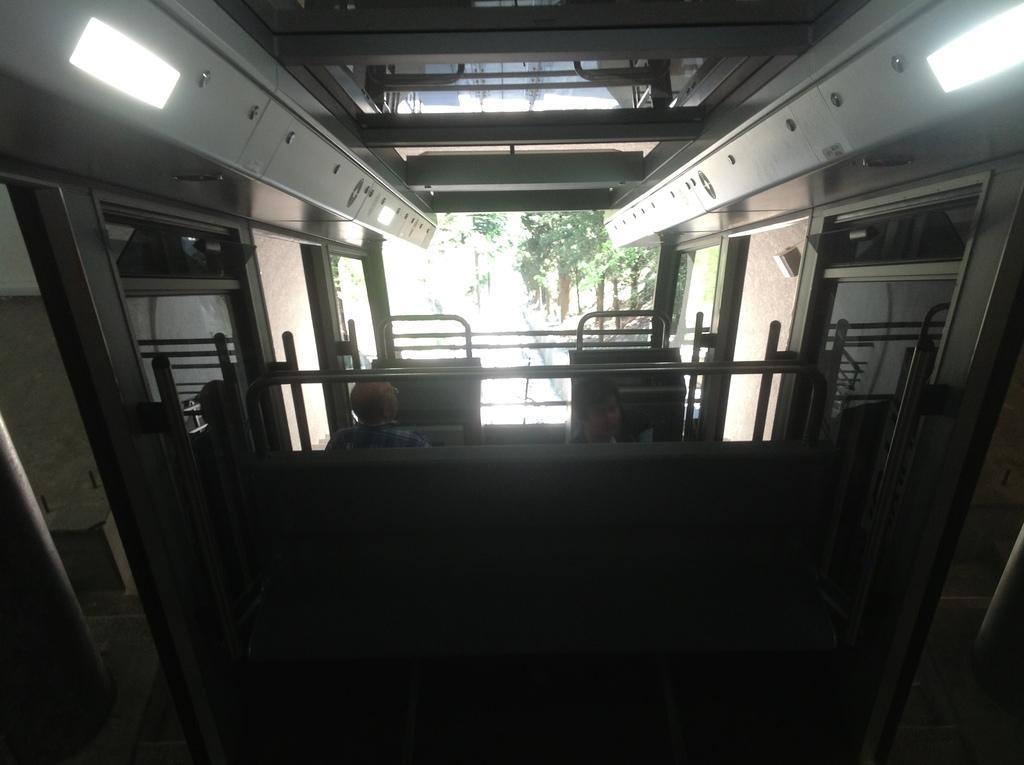Can you describe this image briefly? In the center of the image there are two persons. In the background of the image there are trees. 